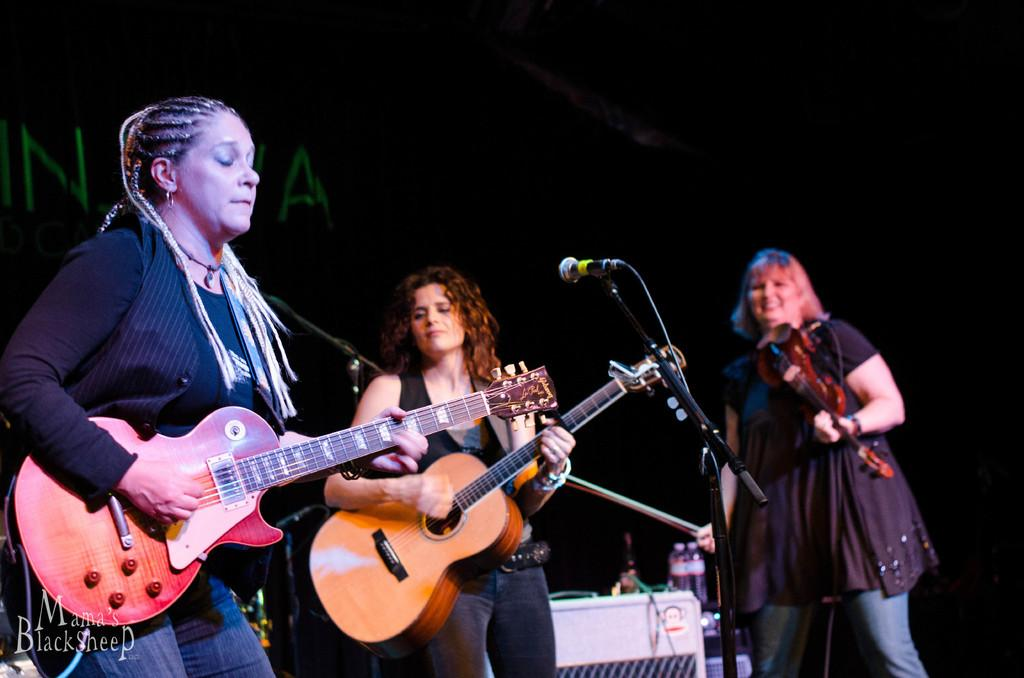How many people are present in the image? There are three persons standing in the image. What are two of the persons holding? Two of the persons are holding guitars. What is the third person holding? One person is holding a musical instrument. What equipment is present for amplifying sound? There is a microphone with a stand in the image. What objects can be seen that are not related to music? There are bottles in the image. What type of stamp is visible on the guitar in the image? There is no stamp visible on the guitar in the image. Can you tell me how many teeth the person holding the microphone has? It is not possible to determine the number of teeth the person holding the microphone has from the image. 